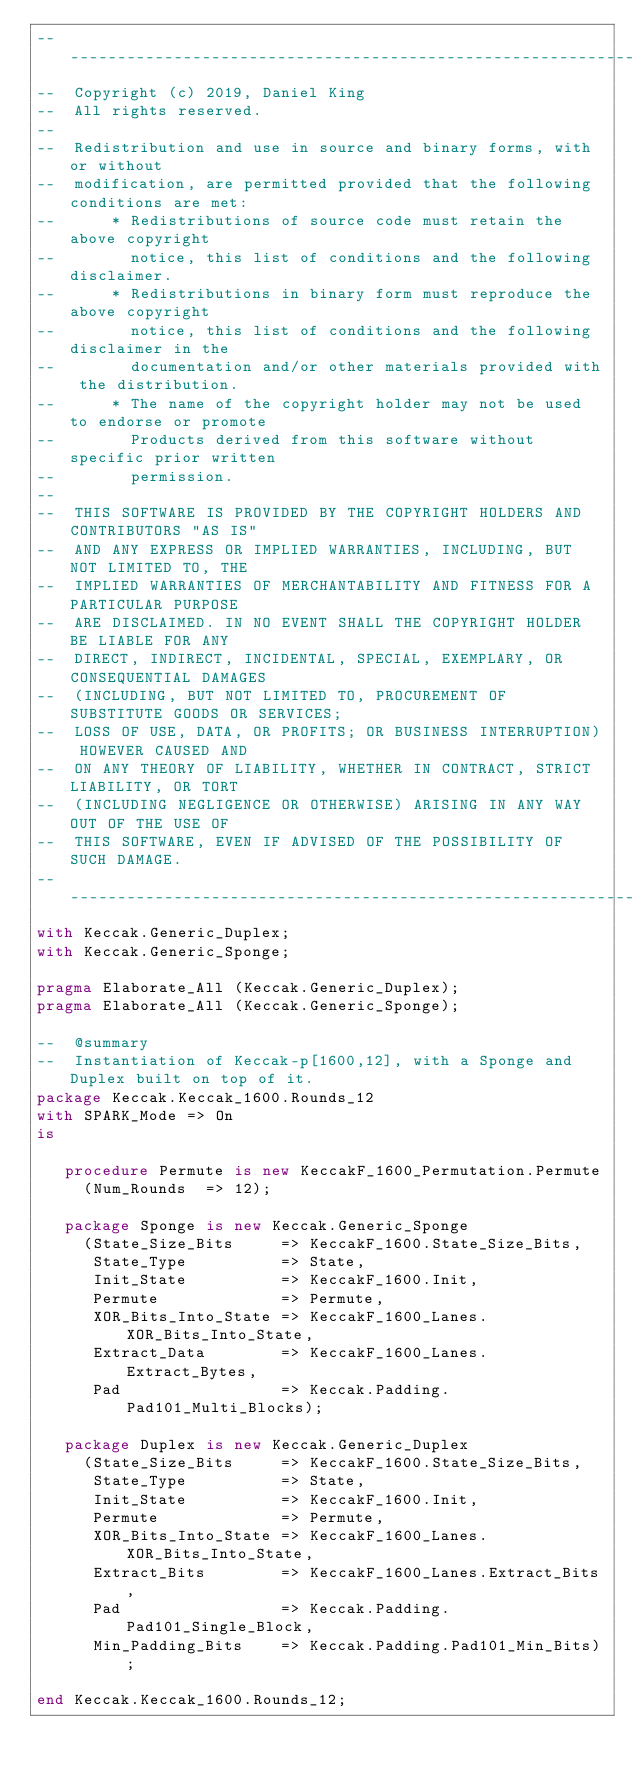<code> <loc_0><loc_0><loc_500><loc_500><_Ada_>-------------------------------------------------------------------------------
--  Copyright (c) 2019, Daniel King
--  All rights reserved.
--
--  Redistribution and use in source and binary forms, with or without
--  modification, are permitted provided that the following conditions are met:
--      * Redistributions of source code must retain the above copyright
--        notice, this list of conditions and the following disclaimer.
--      * Redistributions in binary form must reproduce the above copyright
--        notice, this list of conditions and the following disclaimer in the
--        documentation and/or other materials provided with the distribution.
--      * The name of the copyright holder may not be used to endorse or promote
--        Products derived from this software without specific prior written
--        permission.
--
--  THIS SOFTWARE IS PROVIDED BY THE COPYRIGHT HOLDERS AND CONTRIBUTORS "AS IS"
--  AND ANY EXPRESS OR IMPLIED WARRANTIES, INCLUDING, BUT NOT LIMITED TO, THE
--  IMPLIED WARRANTIES OF MERCHANTABILITY AND FITNESS FOR A PARTICULAR PURPOSE
--  ARE DISCLAIMED. IN NO EVENT SHALL THE COPYRIGHT HOLDER BE LIABLE FOR ANY
--  DIRECT, INDIRECT, INCIDENTAL, SPECIAL, EXEMPLARY, OR CONSEQUENTIAL DAMAGES
--  (INCLUDING, BUT NOT LIMITED TO, PROCUREMENT OF SUBSTITUTE GOODS OR SERVICES;
--  LOSS OF USE, DATA, OR PROFITS; OR BUSINESS INTERRUPTION) HOWEVER CAUSED AND
--  ON ANY THEORY OF LIABILITY, WHETHER IN CONTRACT, STRICT LIABILITY, OR TORT
--  (INCLUDING NEGLIGENCE OR OTHERWISE) ARISING IN ANY WAY OUT OF THE USE OF
--  THIS SOFTWARE, EVEN IF ADVISED OF THE POSSIBILITY OF SUCH DAMAGE.
-------------------------------------------------------------------------------
with Keccak.Generic_Duplex;
with Keccak.Generic_Sponge;

pragma Elaborate_All (Keccak.Generic_Duplex);
pragma Elaborate_All (Keccak.Generic_Sponge);

--  @summary
--  Instantiation of Keccak-p[1600,12], with a Sponge and Duplex built on top of it.
package Keccak.Keccak_1600.Rounds_12
with SPARK_Mode => On
is

   procedure Permute is new KeccakF_1600_Permutation.Permute
     (Num_Rounds  => 12);

   package Sponge is new Keccak.Generic_Sponge
     (State_Size_Bits     => KeccakF_1600.State_Size_Bits,
      State_Type          => State,
      Init_State          => KeccakF_1600.Init,
      Permute             => Permute,
      XOR_Bits_Into_State => KeccakF_1600_Lanes.XOR_Bits_Into_State,
      Extract_Data        => KeccakF_1600_Lanes.Extract_Bytes,
      Pad                 => Keccak.Padding.Pad101_Multi_Blocks);

   package Duplex is new Keccak.Generic_Duplex
     (State_Size_Bits     => KeccakF_1600.State_Size_Bits,
      State_Type          => State,
      Init_State          => KeccakF_1600.Init,
      Permute             => Permute,
      XOR_Bits_Into_State => KeccakF_1600_Lanes.XOR_Bits_Into_State,
      Extract_Bits        => KeccakF_1600_Lanes.Extract_Bits,
      Pad                 => Keccak.Padding.Pad101_Single_Block,
      Min_Padding_Bits    => Keccak.Padding.Pad101_Min_Bits);

end Keccak.Keccak_1600.Rounds_12;
</code> 